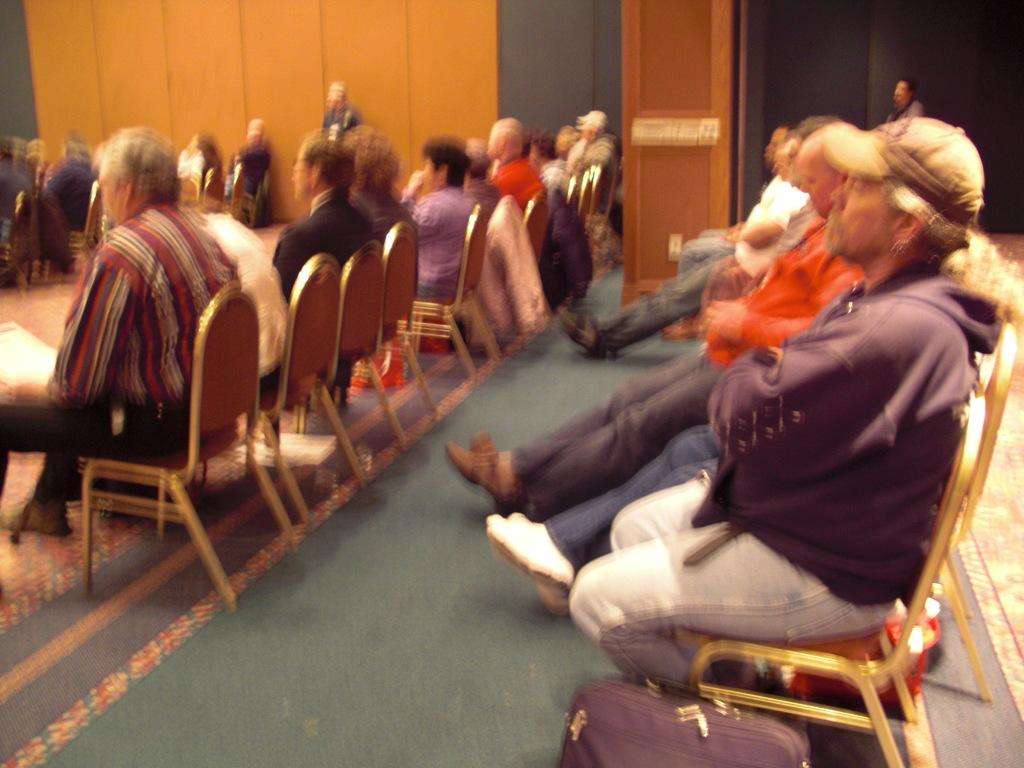What are the people in the image doing? The people in the image are sitting on chairs in a room. Can you describe any objects at the bottom of the image? There is a bag at the bottom of the image. What architectural feature can be seen in the image? There is a pillar visible in the image. Can you see any lakes in the image? There are no lakes present in the image; it features people sitting in a room with a bag and a pillar. What type of thread is being used to sew the chairs in the image? There is no thread visible in the image, as it focuses on the people sitting on the chairs and the presence of a bag and a pillar. 